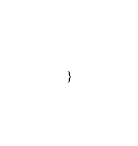<code> <loc_0><loc_0><loc_500><loc_500><_CSS_>}</code> 